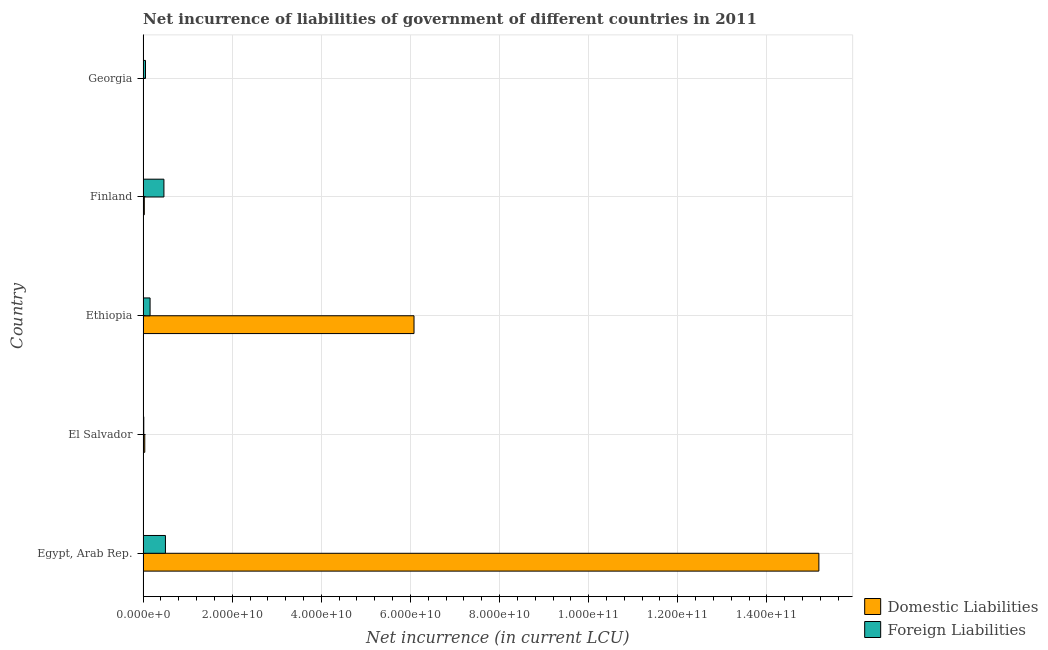How many different coloured bars are there?
Ensure brevity in your answer.  2. How many groups of bars are there?
Ensure brevity in your answer.  5. Are the number of bars per tick equal to the number of legend labels?
Make the answer very short. Yes. Are the number of bars on each tick of the Y-axis equal?
Offer a very short reply. Yes. How many bars are there on the 4th tick from the top?
Your answer should be compact. 2. What is the label of the 3rd group of bars from the top?
Give a very brief answer. Ethiopia. What is the net incurrence of foreign liabilities in Egypt, Arab Rep.?
Ensure brevity in your answer.  5.02e+09. Across all countries, what is the maximum net incurrence of domestic liabilities?
Your response must be concise. 1.52e+11. Across all countries, what is the minimum net incurrence of domestic liabilities?
Ensure brevity in your answer.  3.52e+07. In which country was the net incurrence of domestic liabilities maximum?
Give a very brief answer. Egypt, Arab Rep. In which country was the net incurrence of domestic liabilities minimum?
Provide a succinct answer. Georgia. What is the total net incurrence of foreign liabilities in the graph?
Keep it short and to the point. 1.20e+1. What is the difference between the net incurrence of domestic liabilities in Finland and that in Georgia?
Your answer should be very brief. 2.46e+08. What is the difference between the net incurrence of domestic liabilities in Georgia and the net incurrence of foreign liabilities in El Salvador?
Offer a very short reply. -1.26e+08. What is the average net incurrence of foreign liabilities per country?
Keep it short and to the point. 2.40e+09. What is the difference between the net incurrence of foreign liabilities and net incurrence of domestic liabilities in Finland?
Ensure brevity in your answer.  4.40e+09. What is the ratio of the net incurrence of foreign liabilities in Egypt, Arab Rep. to that in El Salvador?
Keep it short and to the point. 31.06. What is the difference between the highest and the second highest net incurrence of domestic liabilities?
Provide a succinct answer. 9.09e+1. What is the difference between the highest and the lowest net incurrence of foreign liabilities?
Keep it short and to the point. 4.86e+09. Is the sum of the net incurrence of foreign liabilities in Egypt, Arab Rep. and Georgia greater than the maximum net incurrence of domestic liabilities across all countries?
Keep it short and to the point. No. What does the 2nd bar from the top in El Salvador represents?
Ensure brevity in your answer.  Domestic Liabilities. What does the 1st bar from the bottom in Georgia represents?
Offer a very short reply. Domestic Liabilities. Are all the bars in the graph horizontal?
Your response must be concise. Yes. What is the difference between two consecutive major ticks on the X-axis?
Give a very brief answer. 2.00e+1. Are the values on the major ticks of X-axis written in scientific E-notation?
Provide a short and direct response. Yes. Does the graph contain any zero values?
Your response must be concise. No. Does the graph contain grids?
Provide a succinct answer. Yes. What is the title of the graph?
Make the answer very short. Net incurrence of liabilities of government of different countries in 2011. Does "GDP per capita" appear as one of the legend labels in the graph?
Provide a succinct answer. No. What is the label or title of the X-axis?
Your answer should be compact. Net incurrence (in current LCU). What is the label or title of the Y-axis?
Your answer should be very brief. Country. What is the Net incurrence (in current LCU) in Domestic Liabilities in Egypt, Arab Rep.?
Offer a terse response. 1.52e+11. What is the Net incurrence (in current LCU) of Foreign Liabilities in Egypt, Arab Rep.?
Your answer should be very brief. 5.02e+09. What is the Net incurrence (in current LCU) in Domestic Liabilities in El Salvador?
Provide a succinct answer. 3.81e+08. What is the Net incurrence (in current LCU) of Foreign Liabilities in El Salvador?
Offer a terse response. 1.62e+08. What is the Net incurrence (in current LCU) of Domestic Liabilities in Ethiopia?
Provide a short and direct response. 6.08e+1. What is the Net incurrence (in current LCU) in Foreign Liabilities in Ethiopia?
Your answer should be compact. 1.57e+09. What is the Net incurrence (in current LCU) in Domestic Liabilities in Finland?
Keep it short and to the point. 2.81e+08. What is the Net incurrence (in current LCU) of Foreign Liabilities in Finland?
Make the answer very short. 4.68e+09. What is the Net incurrence (in current LCU) in Domestic Liabilities in Georgia?
Your answer should be very brief. 3.52e+07. What is the Net incurrence (in current LCU) of Foreign Liabilities in Georgia?
Provide a short and direct response. 5.48e+08. Across all countries, what is the maximum Net incurrence (in current LCU) of Domestic Liabilities?
Your answer should be very brief. 1.52e+11. Across all countries, what is the maximum Net incurrence (in current LCU) in Foreign Liabilities?
Your response must be concise. 5.02e+09. Across all countries, what is the minimum Net incurrence (in current LCU) of Domestic Liabilities?
Your answer should be very brief. 3.52e+07. Across all countries, what is the minimum Net incurrence (in current LCU) in Foreign Liabilities?
Your response must be concise. 1.62e+08. What is the total Net incurrence (in current LCU) in Domestic Liabilities in the graph?
Your response must be concise. 2.13e+11. What is the total Net incurrence (in current LCU) of Foreign Liabilities in the graph?
Offer a terse response. 1.20e+1. What is the difference between the Net incurrence (in current LCU) of Domestic Liabilities in Egypt, Arab Rep. and that in El Salvador?
Your answer should be very brief. 1.51e+11. What is the difference between the Net incurrence (in current LCU) in Foreign Liabilities in Egypt, Arab Rep. and that in El Salvador?
Your answer should be very brief. 4.86e+09. What is the difference between the Net incurrence (in current LCU) in Domestic Liabilities in Egypt, Arab Rep. and that in Ethiopia?
Offer a very short reply. 9.09e+1. What is the difference between the Net incurrence (in current LCU) in Foreign Liabilities in Egypt, Arab Rep. and that in Ethiopia?
Provide a succinct answer. 3.45e+09. What is the difference between the Net incurrence (in current LCU) of Domestic Liabilities in Egypt, Arab Rep. and that in Finland?
Offer a terse response. 1.51e+11. What is the difference between the Net incurrence (in current LCU) in Foreign Liabilities in Egypt, Arab Rep. and that in Finland?
Ensure brevity in your answer.  3.42e+08. What is the difference between the Net incurrence (in current LCU) of Domestic Liabilities in Egypt, Arab Rep. and that in Georgia?
Ensure brevity in your answer.  1.52e+11. What is the difference between the Net incurrence (in current LCU) of Foreign Liabilities in Egypt, Arab Rep. and that in Georgia?
Offer a very short reply. 4.47e+09. What is the difference between the Net incurrence (in current LCU) in Domestic Liabilities in El Salvador and that in Ethiopia?
Make the answer very short. -6.04e+1. What is the difference between the Net incurrence (in current LCU) in Foreign Liabilities in El Salvador and that in Ethiopia?
Offer a terse response. -1.41e+09. What is the difference between the Net incurrence (in current LCU) in Domestic Liabilities in El Salvador and that in Finland?
Provide a succinct answer. 1.00e+08. What is the difference between the Net incurrence (in current LCU) in Foreign Liabilities in El Salvador and that in Finland?
Keep it short and to the point. -4.52e+09. What is the difference between the Net incurrence (in current LCU) in Domestic Liabilities in El Salvador and that in Georgia?
Your answer should be compact. 3.46e+08. What is the difference between the Net incurrence (in current LCU) in Foreign Liabilities in El Salvador and that in Georgia?
Offer a very short reply. -3.86e+08. What is the difference between the Net incurrence (in current LCU) of Domestic Liabilities in Ethiopia and that in Finland?
Your answer should be very brief. 6.05e+1. What is the difference between the Net incurrence (in current LCU) in Foreign Liabilities in Ethiopia and that in Finland?
Offer a very short reply. -3.11e+09. What is the difference between the Net incurrence (in current LCU) in Domestic Liabilities in Ethiopia and that in Georgia?
Your answer should be compact. 6.08e+1. What is the difference between the Net incurrence (in current LCU) of Foreign Liabilities in Ethiopia and that in Georgia?
Your answer should be compact. 1.03e+09. What is the difference between the Net incurrence (in current LCU) in Domestic Liabilities in Finland and that in Georgia?
Provide a succinct answer. 2.46e+08. What is the difference between the Net incurrence (in current LCU) of Foreign Liabilities in Finland and that in Georgia?
Keep it short and to the point. 4.13e+09. What is the difference between the Net incurrence (in current LCU) of Domestic Liabilities in Egypt, Arab Rep. and the Net incurrence (in current LCU) of Foreign Liabilities in El Salvador?
Your answer should be very brief. 1.52e+11. What is the difference between the Net incurrence (in current LCU) of Domestic Liabilities in Egypt, Arab Rep. and the Net incurrence (in current LCU) of Foreign Liabilities in Ethiopia?
Give a very brief answer. 1.50e+11. What is the difference between the Net incurrence (in current LCU) in Domestic Liabilities in Egypt, Arab Rep. and the Net incurrence (in current LCU) in Foreign Liabilities in Finland?
Make the answer very short. 1.47e+11. What is the difference between the Net incurrence (in current LCU) in Domestic Liabilities in Egypt, Arab Rep. and the Net incurrence (in current LCU) in Foreign Liabilities in Georgia?
Ensure brevity in your answer.  1.51e+11. What is the difference between the Net incurrence (in current LCU) of Domestic Liabilities in El Salvador and the Net incurrence (in current LCU) of Foreign Liabilities in Ethiopia?
Provide a succinct answer. -1.19e+09. What is the difference between the Net incurrence (in current LCU) in Domestic Liabilities in El Salvador and the Net incurrence (in current LCU) in Foreign Liabilities in Finland?
Offer a very short reply. -4.30e+09. What is the difference between the Net incurrence (in current LCU) of Domestic Liabilities in El Salvador and the Net incurrence (in current LCU) of Foreign Liabilities in Georgia?
Offer a very short reply. -1.67e+08. What is the difference between the Net incurrence (in current LCU) in Domestic Liabilities in Ethiopia and the Net incurrence (in current LCU) in Foreign Liabilities in Finland?
Your answer should be compact. 5.61e+1. What is the difference between the Net incurrence (in current LCU) of Domestic Liabilities in Ethiopia and the Net incurrence (in current LCU) of Foreign Liabilities in Georgia?
Provide a short and direct response. 6.03e+1. What is the difference between the Net incurrence (in current LCU) in Domestic Liabilities in Finland and the Net incurrence (in current LCU) in Foreign Liabilities in Georgia?
Offer a terse response. -2.67e+08. What is the average Net incurrence (in current LCU) of Domestic Liabilities per country?
Give a very brief answer. 4.26e+1. What is the average Net incurrence (in current LCU) in Foreign Liabilities per country?
Your response must be concise. 2.40e+09. What is the difference between the Net incurrence (in current LCU) in Domestic Liabilities and Net incurrence (in current LCU) in Foreign Liabilities in Egypt, Arab Rep.?
Offer a terse response. 1.47e+11. What is the difference between the Net incurrence (in current LCU) of Domestic Liabilities and Net incurrence (in current LCU) of Foreign Liabilities in El Salvador?
Provide a succinct answer. 2.20e+08. What is the difference between the Net incurrence (in current LCU) of Domestic Liabilities and Net incurrence (in current LCU) of Foreign Liabilities in Ethiopia?
Offer a very short reply. 5.92e+1. What is the difference between the Net incurrence (in current LCU) in Domestic Liabilities and Net incurrence (in current LCU) in Foreign Liabilities in Finland?
Your answer should be compact. -4.40e+09. What is the difference between the Net incurrence (in current LCU) in Domestic Liabilities and Net incurrence (in current LCU) in Foreign Liabilities in Georgia?
Provide a short and direct response. -5.13e+08. What is the ratio of the Net incurrence (in current LCU) of Domestic Liabilities in Egypt, Arab Rep. to that in El Salvador?
Offer a very short reply. 397.6. What is the ratio of the Net incurrence (in current LCU) of Foreign Liabilities in Egypt, Arab Rep. to that in El Salvador?
Offer a terse response. 31.06. What is the ratio of the Net incurrence (in current LCU) of Domestic Liabilities in Egypt, Arab Rep. to that in Ethiopia?
Provide a short and direct response. 2.49. What is the ratio of the Net incurrence (in current LCU) in Foreign Liabilities in Egypt, Arab Rep. to that in Ethiopia?
Give a very brief answer. 3.19. What is the ratio of the Net incurrence (in current LCU) of Domestic Liabilities in Egypt, Arab Rep. to that in Finland?
Your answer should be very brief. 539.73. What is the ratio of the Net incurrence (in current LCU) of Foreign Liabilities in Egypt, Arab Rep. to that in Finland?
Your answer should be compact. 1.07. What is the ratio of the Net incurrence (in current LCU) in Domestic Liabilities in Egypt, Arab Rep. to that in Georgia?
Provide a short and direct response. 4308.64. What is the ratio of the Net incurrence (in current LCU) in Foreign Liabilities in Egypt, Arab Rep. to that in Georgia?
Your answer should be compact. 9.16. What is the ratio of the Net incurrence (in current LCU) in Domestic Liabilities in El Salvador to that in Ethiopia?
Provide a succinct answer. 0.01. What is the ratio of the Net incurrence (in current LCU) of Foreign Liabilities in El Salvador to that in Ethiopia?
Your answer should be very brief. 0.1. What is the ratio of the Net incurrence (in current LCU) of Domestic Liabilities in El Salvador to that in Finland?
Give a very brief answer. 1.36. What is the ratio of the Net incurrence (in current LCU) in Foreign Liabilities in El Salvador to that in Finland?
Make the answer very short. 0.03. What is the ratio of the Net incurrence (in current LCU) of Domestic Liabilities in El Salvador to that in Georgia?
Your answer should be very brief. 10.84. What is the ratio of the Net incurrence (in current LCU) of Foreign Liabilities in El Salvador to that in Georgia?
Your answer should be very brief. 0.3. What is the ratio of the Net incurrence (in current LCU) of Domestic Liabilities in Ethiopia to that in Finland?
Your response must be concise. 216.4. What is the ratio of the Net incurrence (in current LCU) in Foreign Liabilities in Ethiopia to that in Finland?
Keep it short and to the point. 0.34. What is the ratio of the Net incurrence (in current LCU) of Domestic Liabilities in Ethiopia to that in Georgia?
Give a very brief answer. 1727.5. What is the ratio of the Net incurrence (in current LCU) of Foreign Liabilities in Ethiopia to that in Georgia?
Offer a terse response. 2.87. What is the ratio of the Net incurrence (in current LCU) of Domestic Liabilities in Finland to that in Georgia?
Your response must be concise. 7.98. What is the ratio of the Net incurrence (in current LCU) of Foreign Liabilities in Finland to that in Georgia?
Provide a short and direct response. 8.54. What is the difference between the highest and the second highest Net incurrence (in current LCU) in Domestic Liabilities?
Give a very brief answer. 9.09e+1. What is the difference between the highest and the second highest Net incurrence (in current LCU) of Foreign Liabilities?
Make the answer very short. 3.42e+08. What is the difference between the highest and the lowest Net incurrence (in current LCU) of Domestic Liabilities?
Your answer should be very brief. 1.52e+11. What is the difference between the highest and the lowest Net incurrence (in current LCU) of Foreign Liabilities?
Provide a succinct answer. 4.86e+09. 